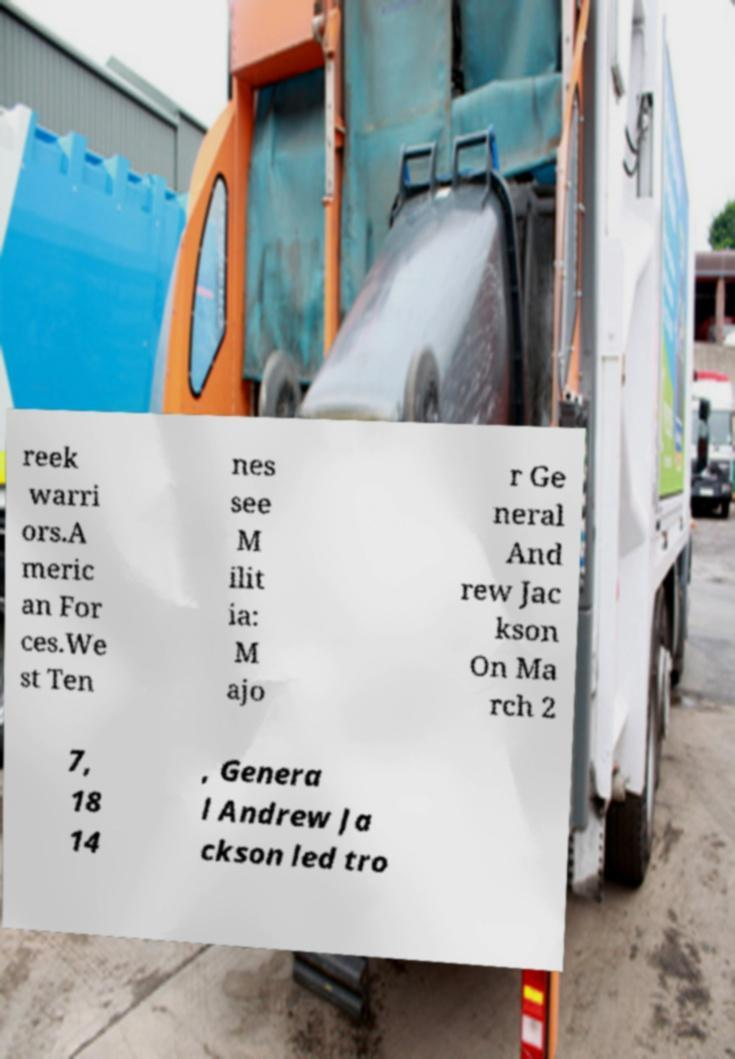I need the written content from this picture converted into text. Can you do that? reek warri ors.A meric an For ces.We st Ten nes see M ilit ia: M ajo r Ge neral And rew Jac kson On Ma rch 2 7, 18 14 , Genera l Andrew Ja ckson led tro 